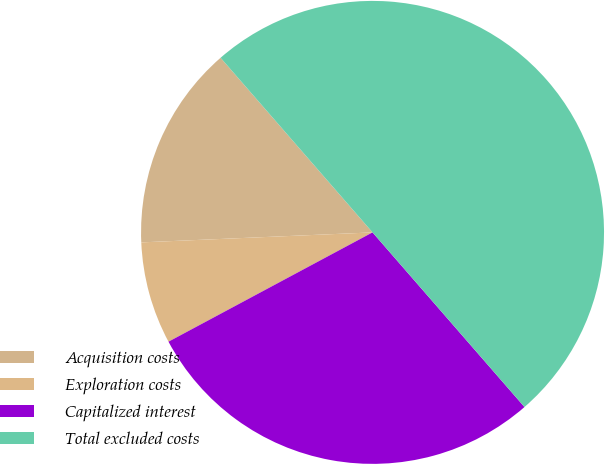Convert chart to OTSL. <chart><loc_0><loc_0><loc_500><loc_500><pie_chart><fcel>Acquisition costs<fcel>Exploration costs<fcel>Capitalized interest<fcel>Total excluded costs<nl><fcel>14.29%<fcel>7.14%<fcel>28.57%<fcel>50.0%<nl></chart> 